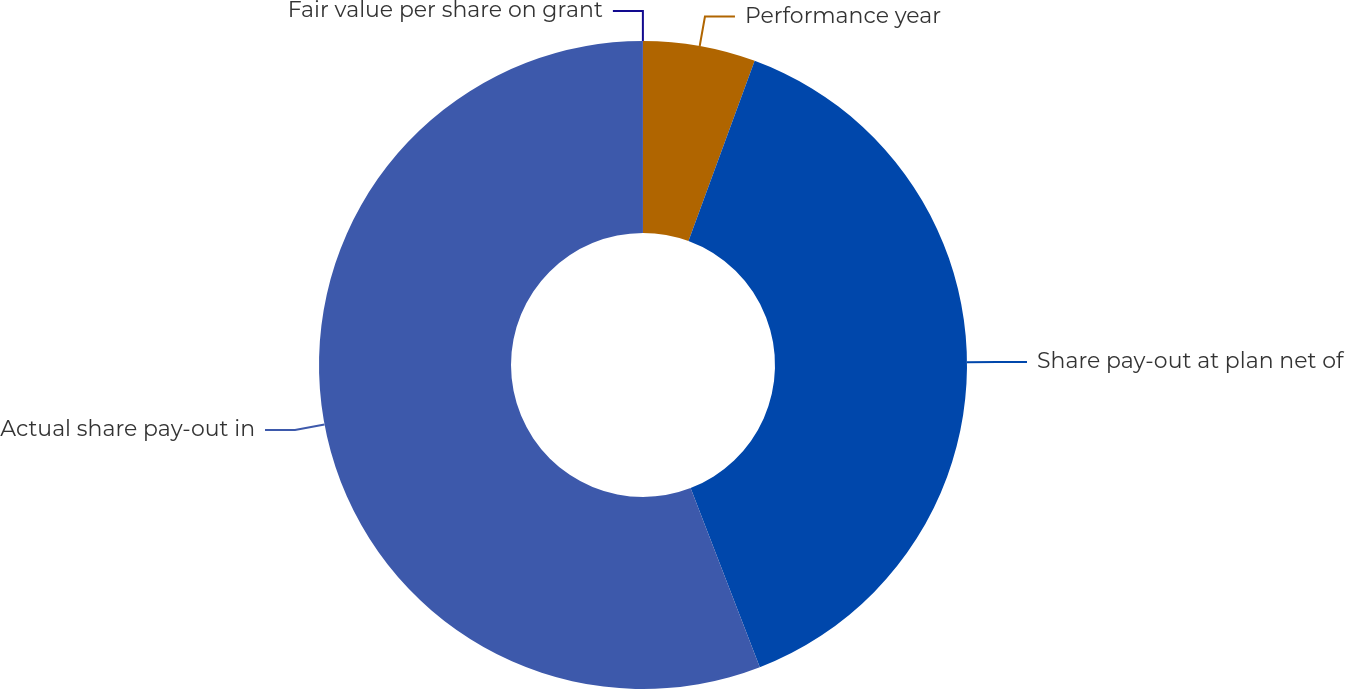Convert chart to OTSL. <chart><loc_0><loc_0><loc_500><loc_500><pie_chart><fcel>Performance year<fcel>Share pay-out at plan net of<fcel>Actual share pay-out in<fcel>Fair value per share on grant<nl><fcel>5.6%<fcel>38.53%<fcel>55.86%<fcel>0.01%<nl></chart> 